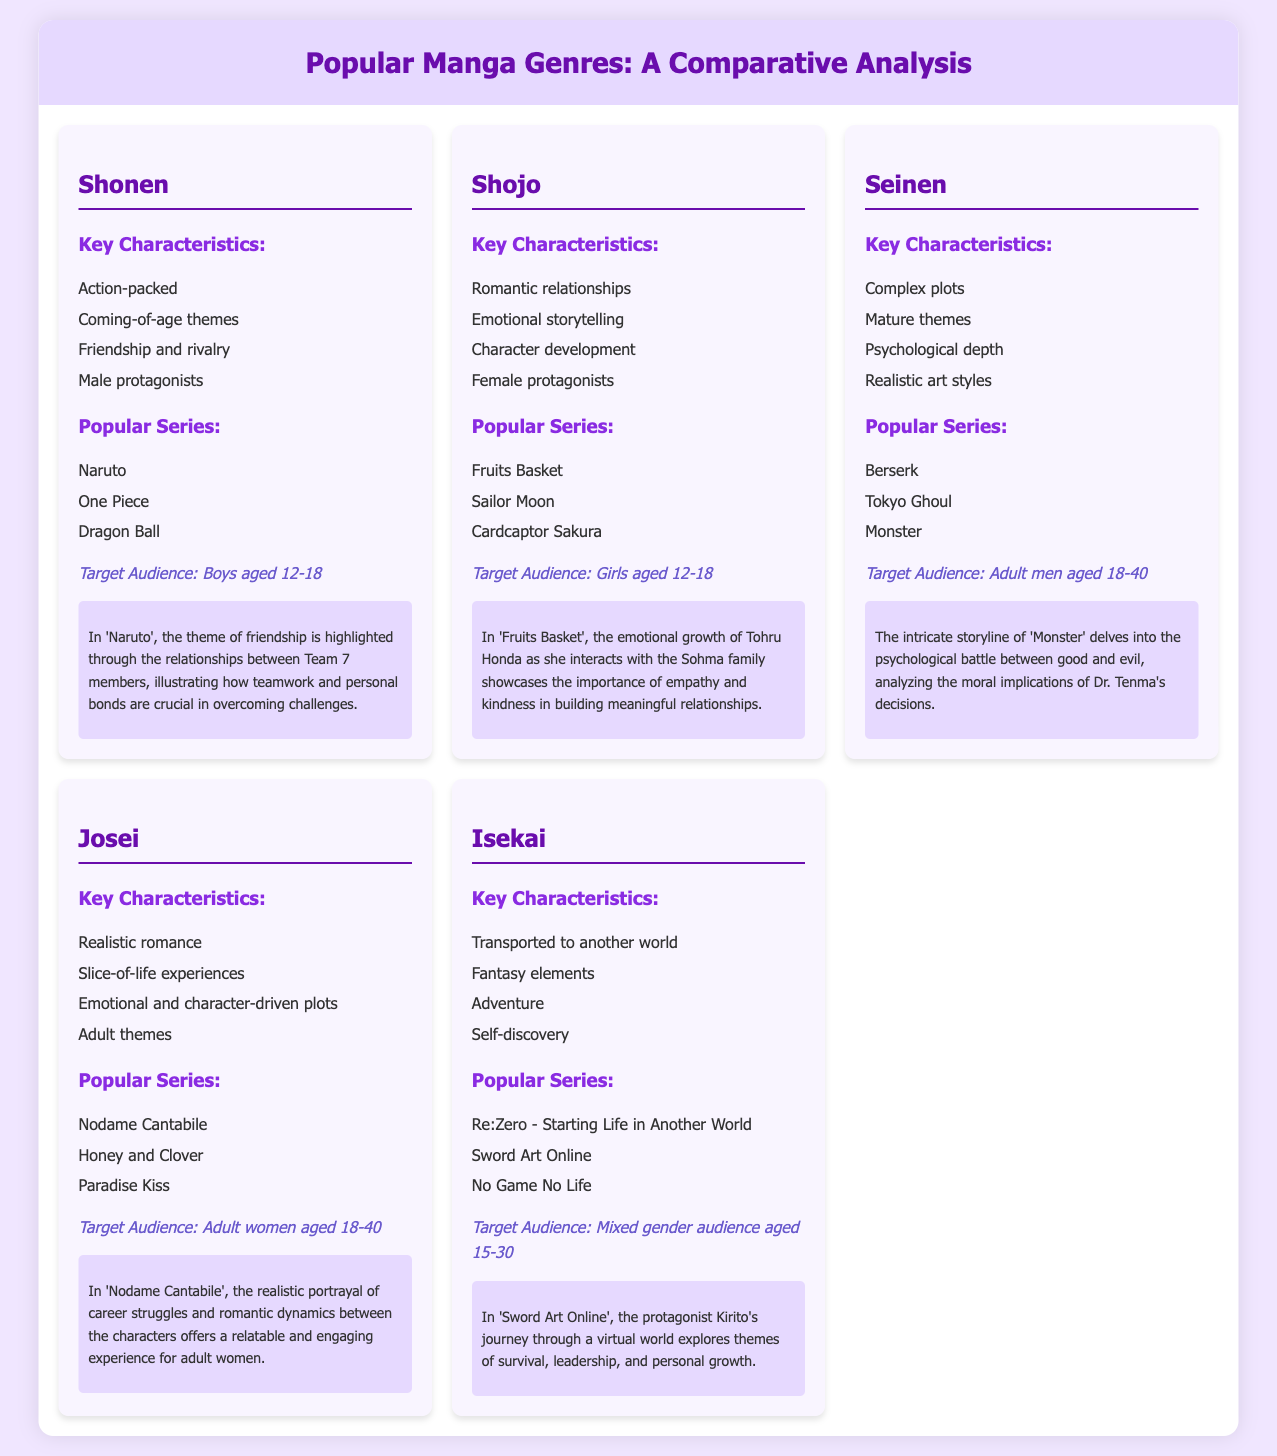What is the target audience for Shonen manga? The target audience for Shonen manga is specified as boys aged 12-18.
Answer: boys aged 12-18 Which popular series is associated with the Isekai genre? One of the popular series in the Isekai genre listed in the document is 'Sword Art Online'.
Answer: Sword Art Online What is a key characteristic of Josei manga? A key characteristic of Josei manga is its realistic romance.
Answer: realistic romance How many popular series are mentioned for the Shojo genre? There are three popular series mentioned for the Shojo genre in the document.
Answer: three Which demographic does Seinen manga primarily target? Seinen manga primarily targets adult men aged 18-40.
Answer: adult men aged 18-40 What theme is highlighted in 'Naruto'? The theme highlighted in 'Naruto' is friendship.
Answer: friendship What aspect of storytelling is emphasized in Shojo manga? Emotional storytelling is emphasized in Shojo manga.
Answer: Emotional storytelling Which genre features male protagonists? The genre featuring male protagonists is Shonen.
Answer: Shonen Name a key theme present in 'Fruits Basket'. A key theme present in 'Fruits Basket' is empathy.
Answer: empathy What do the majority of Isekai stories revolve around? The majority of Isekai stories revolve around self-discovery.
Answer: self-discovery 